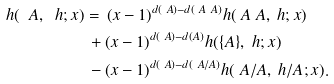Convert formula to latex. <formula><loc_0><loc_0><loc_500><loc_500>h ( \ A , \ h ; x ) & = \, ( x - 1 ) ^ { d ( \ A ) - d ( \ A \ A ) } h ( \ A \ A , \ h ; x ) \\ & \, + ( x - 1 ) ^ { d ( \ A ) - d ( A ) } h ( \{ A \} , \ h ; x ) \\ & \, - ( x - 1 ) ^ { d ( \ A ) - d ( \ A / A ) } h ( \ A / A , \ h / A ; x ) .</formula> 